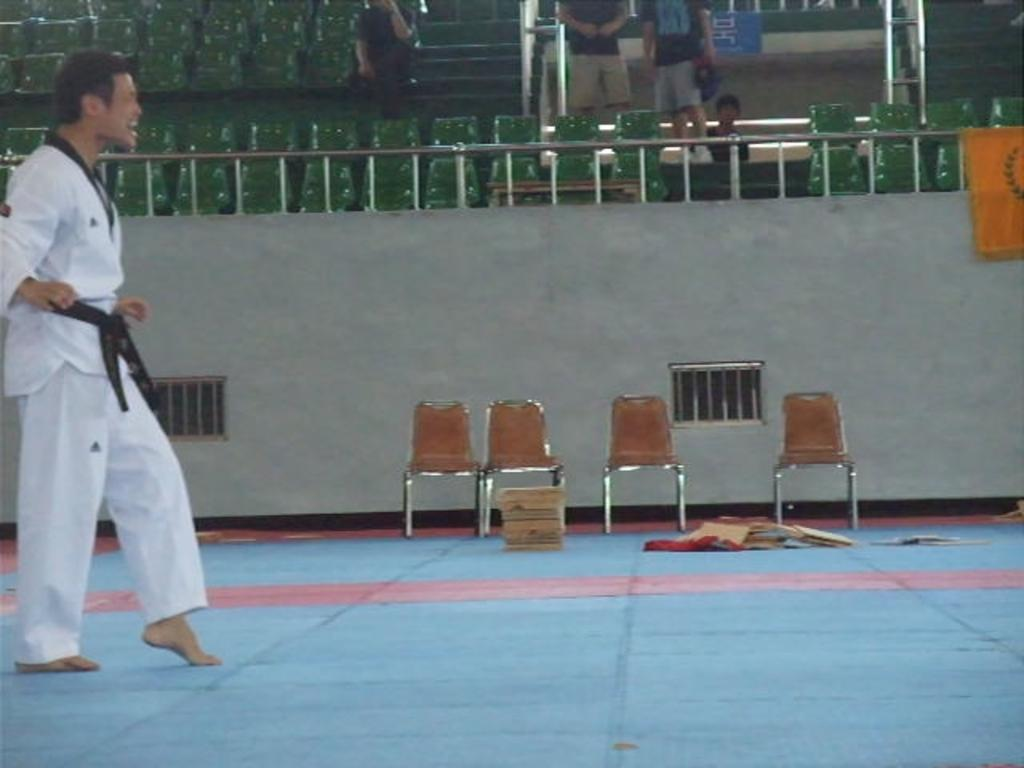What is the position of the man in the image? The man is standing at the left side of the image. What type of furniture can be seen at the top of the image? There are chairs visible at the top of the image. What is the man feeling ashamed about in the image? There is no indication in the image that the man is feeling ashamed, and therefore it cannot be determined from the picture. 